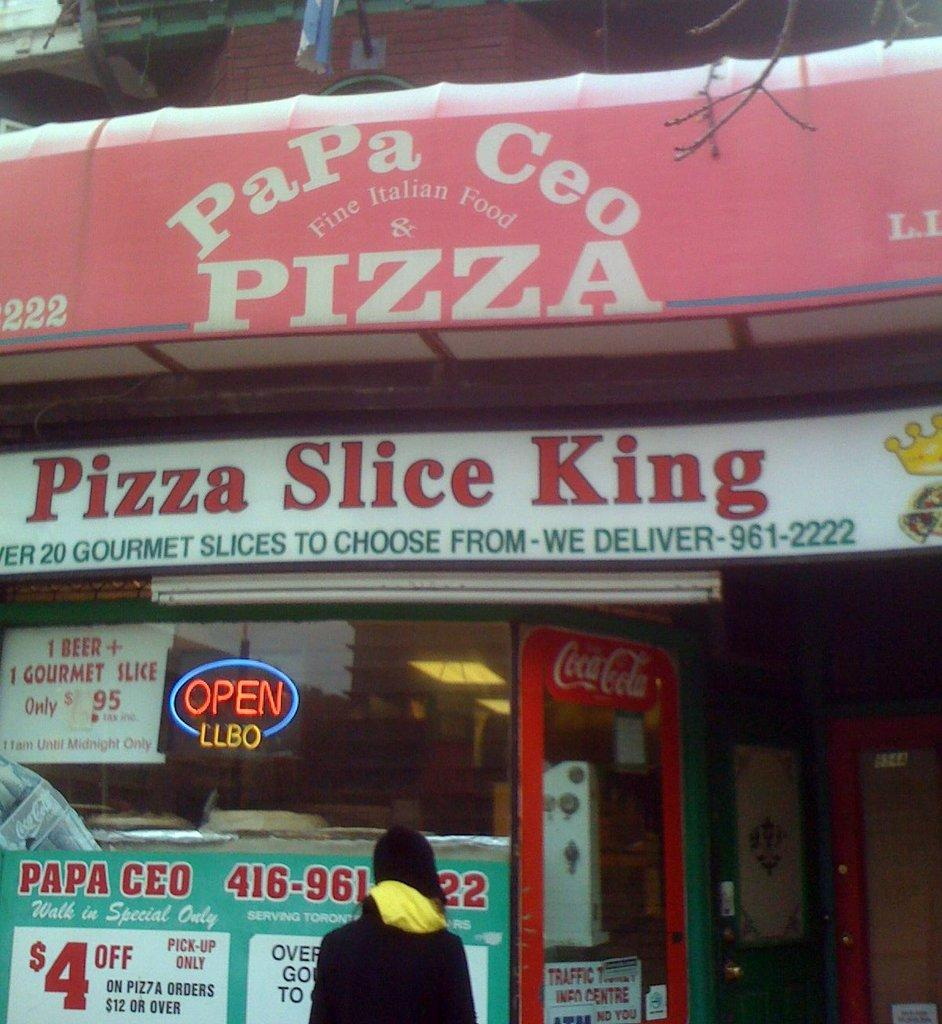Who or what is in the front of the image? There is a person in the front of the image. What can be seen in the background of the image? There are boards in the background of the image. What is written or displayed on the boards? Words are written on the boards. Can you see any ghosts interacting with the person in the image? There are no ghosts present in the image. Are there any cacti visible in the image? There is no mention of cacti in the provided facts, so we cannot determine if they are present in the image. 